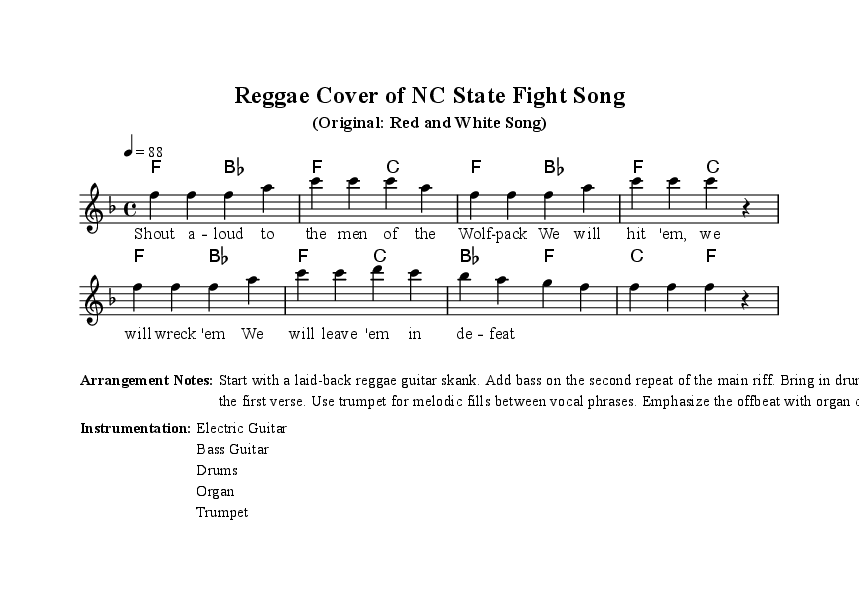What is the key signature of this music? The key signature is F major, which contains one flat (B flat). You can determine the key signature by looking at the first line of the sheet music where the key is indicated.
Answer: F major What is the time signature? The time signature is 4/4, which indicates that there are four beats in each measure. This can be identified in the music notation at the beginning just after the key signature.
Answer: 4/4 What is the tempo marking for this piece? The tempo is marked as quarter note equals 88 beats per minute. This is specified at the beginning of the score following the time signature.
Answer: 88 How many measures are in the melody? There are 8 measures in the melody. Counting the segments divided by vertical lines indicates the number of measures in the score, which can be visually checked from the sheet music itself.
Answer: 8 What instruments are indicated in the instrumentation section? The instrumentation indicates Electric Guitar, Bass Guitar, Drums, Organ, and Trumpet. This is found in the marked section titled "Instrumentation" which lists the instruments used in the arrangement.
Answer: Electric Guitar, Bass Guitar, Drums, Organ, Trumpet What rhythmic style is emphasized in the arrangement notes? The rhythmic style emphasized is the offbeat, as mentioned in the arrangement notes where it states to "Emphasize the offbeat with organ chords." This highlights a common feature in Reggae music.
Answer: Offbeat What element is suggested to be used for melodic fills? The arrangement notes suggest using a trumpet for melodic fills between vocal phrases. This can be found specifically in the arrangement notes section that provides guidance on instrumentation and roles.
Answer: Trumpet 